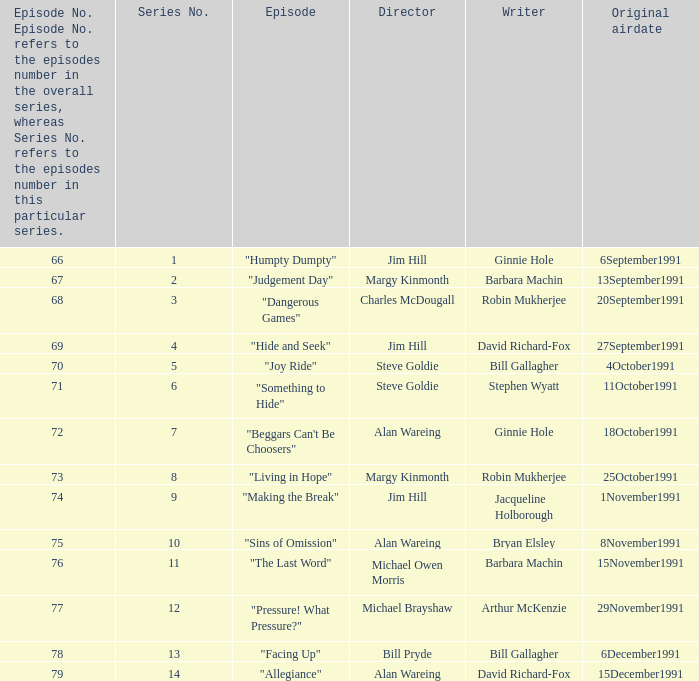State the premiere airdate for robin mukherjee and margy kinmonth. 25October1991. 